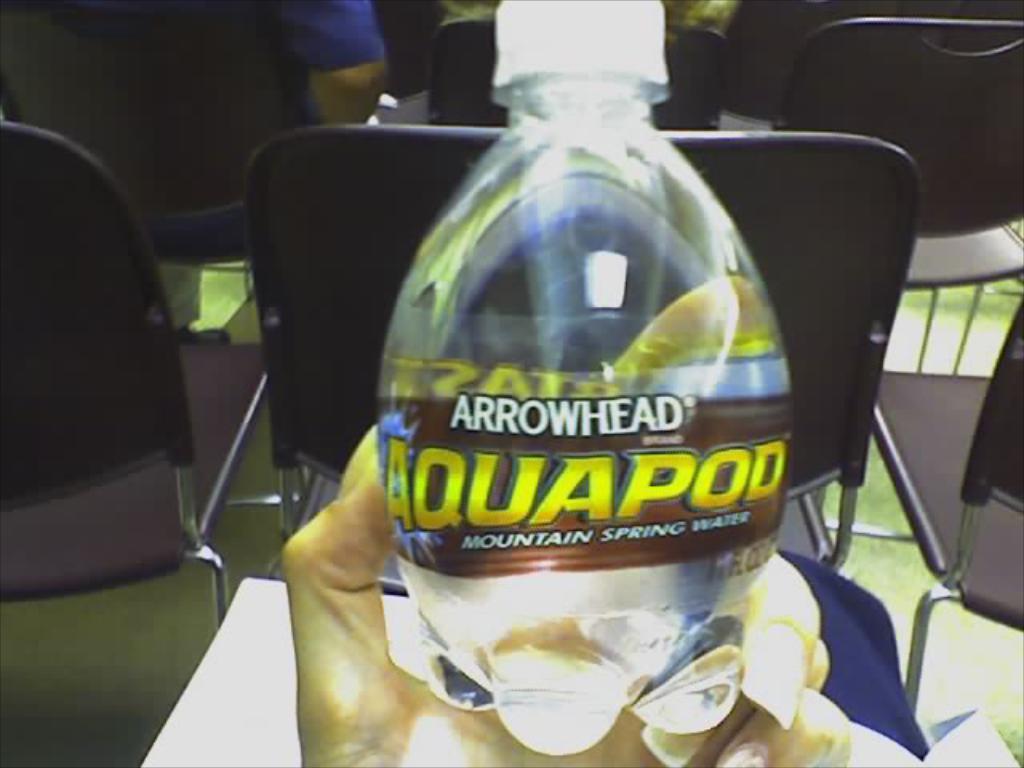How would you summarize this image in a sentence or two? there is a water bottle in hand and a chairs. 